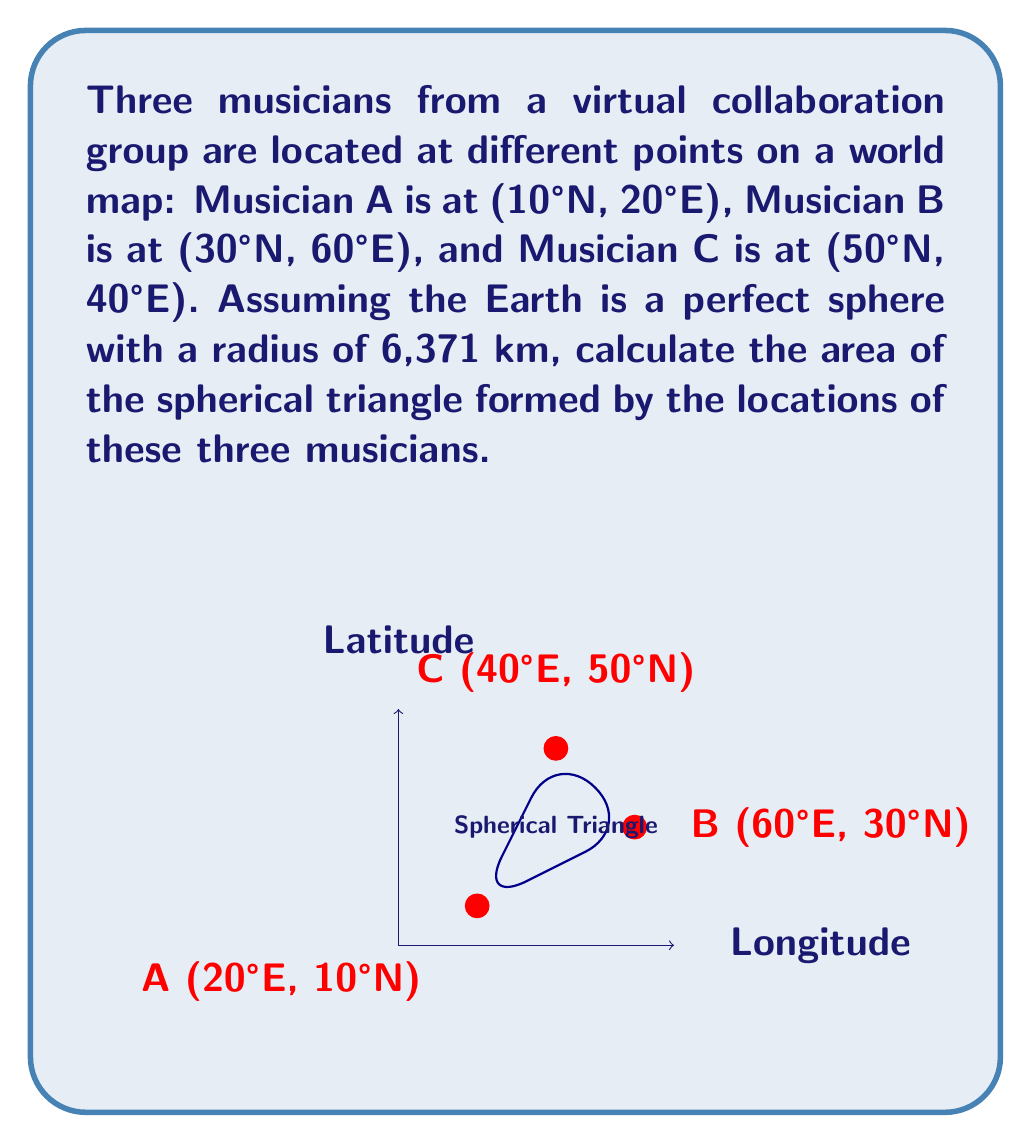Solve this math problem. To find the area of a spherical triangle, we'll use the spherical excess formula:

1) First, we need to calculate the angles of the spherical triangle. We'll use the spherical law of cosines:

   $\cos(a) = \sin(B)\sin(C)\cos(A-C) + \cos(B)\cos(C)$

   Where $a$ is the angle opposite to side $A$, and $A$, $B$, $C$ are the latitudes of the points.

2) Convert latitudes and longitudes to radians:
   A: $(10\pi/180, 20\pi/180)$
   B: $(30\pi/180, 60\pi/180)$
   C: $(50\pi/180, 40\pi/180)$

3) Calculate the angles using the spherical law of cosines:
   $\cos(a) = \sin(30\pi/180)\sin(50\pi/180)\cos(60\pi/180-40\pi/180) + \cos(30\pi/180)\cos(50\pi/180) = 0.7660$
   $a = \arccos(0.7660) = 0.7214$

   Similarly, calculate $b$ and $c$.

4) The spherical excess $E$ is given by:
   $E = A + B + C - \pi$

   Where $A$, $B$, and $C$ are the angles we calculated.

5) The area of the spherical triangle is:
   $Area = R^2 \cdot E$

   Where $R$ is the radius of the Earth (6,371 km).

6) Calculate the final area:
   $Area = 6371^2 \cdot E$
Answer: $2,534,823 \text{ km}^2$ 